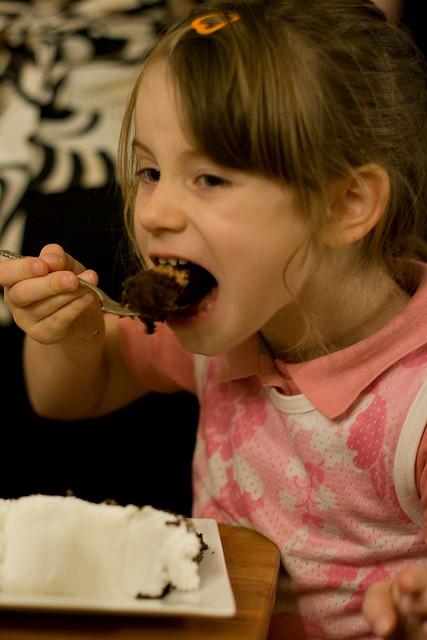Is the cake chocolate?
Quick response, please. Yes. Is this little girl eating food?
Short answer required. Yes. What color is the little girl's shirt?
Quick response, please. Pink. Is someone a bit of a drama queen?
Give a very brief answer. No. 